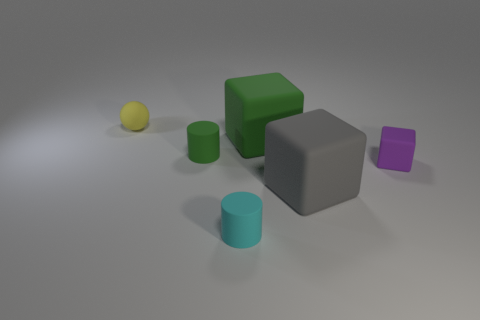Subtract all tiny blocks. How many blocks are left? 2 Add 2 small rubber cylinders. How many objects exist? 8 Subtract all cylinders. How many objects are left? 4 Subtract all yellow matte balls. Subtract all gray things. How many objects are left? 4 Add 3 rubber things. How many rubber things are left? 9 Add 2 green matte cylinders. How many green matte cylinders exist? 3 Subtract 0 yellow cylinders. How many objects are left? 6 